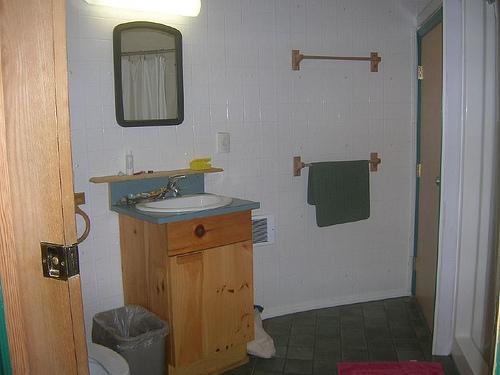Who is in the bathroom?
Concise answer only. No one. Where are the toothbrushes?
Keep it brief. On sink. Has the trash been emptied?
Be succinct. Yes. Are the walls wooden?
Give a very brief answer. No. 